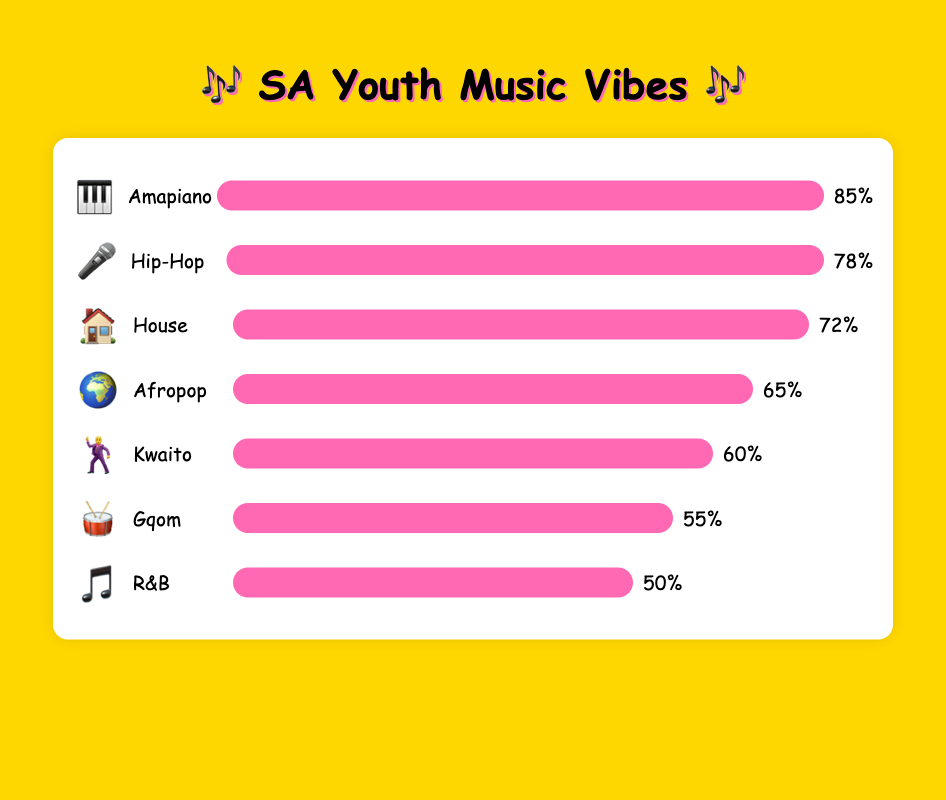What genre is represented by the 🎤 emoji? The emoji 🎤 is placed next to the genre name "Hip-Hop" in the figure.
Answer: Hip-Hop Which music genre is the least popular among South African youth? The bar with the lowest popularity percentage is R&B at 50%.
Answer: R&B What's the difference in popularity between Amapiano and Kwaito? Amapiano has a popularity of 85% and Kwaito has 60%. The difference is calculated by 85 - 60.
Answer: 25% Place the music genres in order from least popular to most popular. The genres are placed in ascending order of their popularity percentages: R&B (50%), Gqom (55%), Kwaito (60%), Afropop (65%), House (72%), Hip-Hop (78%), Amapiano (85%).
Answer: R&B, Gqom, Kwaito, Afropop, House, Hip-Hop, Amapiano Which genre has a popularity percentage greater than Afropop but less than Amapiano? House has a popularity of 72% which is more than Afropop's 65% and less than Amapiano's 85%.
Answer: House What is the combined popularity percentage of Hip-Hop and Gqom? Adding the popularity percentages of Hip-Hop (78%) and Gqom (55%) gives us 78 + 55.
Answer: 133% How many music genres have a popularity percentage above 60%? Counting the genres with popularity percentages of more than 60%: Amapiano, Hip-Hop, House, and Afropop. There are four such genres.
Answer: 4 Which genre has a lower popularity percentage than Kwaito but higher than R&B? Gqom has a popularity of 55%, which is between Kwaito's 60% and R&B's 50%.
Answer: Gqom 